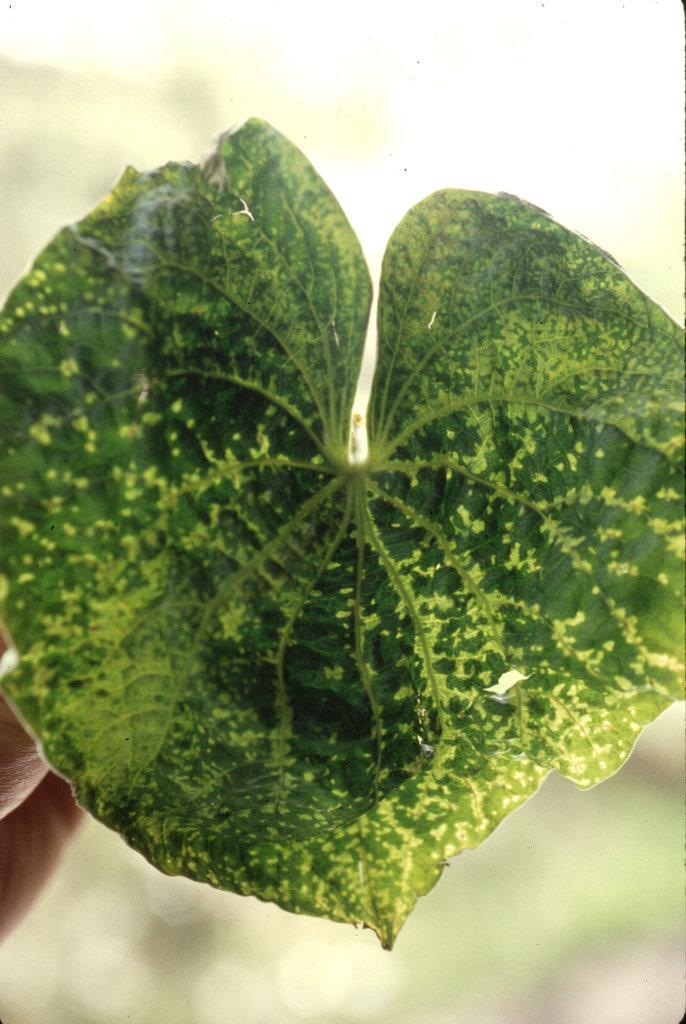What is the main subject of the image? The main subject of the image is a leaf. Can you describe the leaf in the image? The leaf is green in color. What type of toothpaste is being used to clean the leaf in the image? There is no toothpaste or cleaning activity present in the image; it is a zoom-in picture of a leaf. Is the leaf in the image a fictional character from a story? The leaf in the image is a real leaf, not a fictional character from a story. 